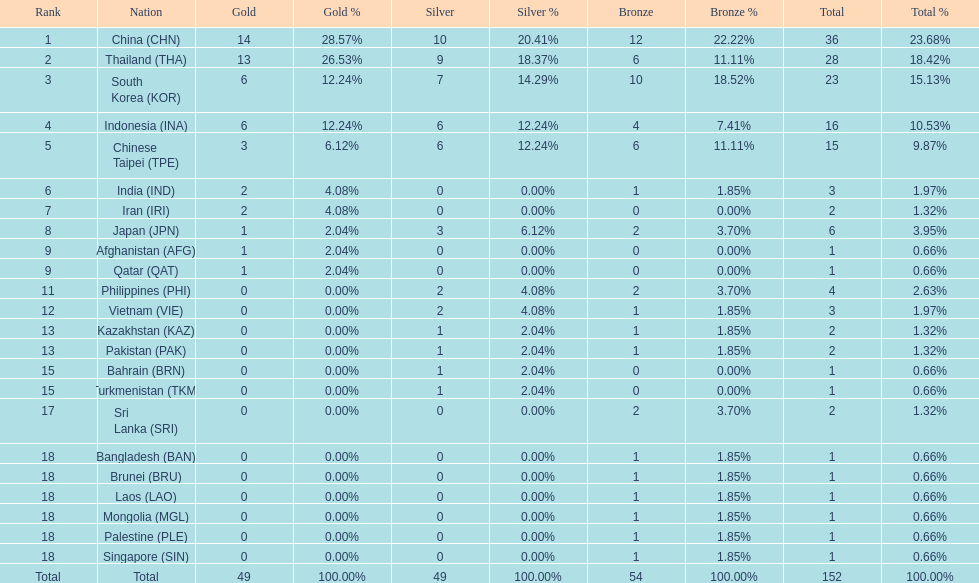Did the philippines or kazakhstan have a higher number of total medals? Philippines. 